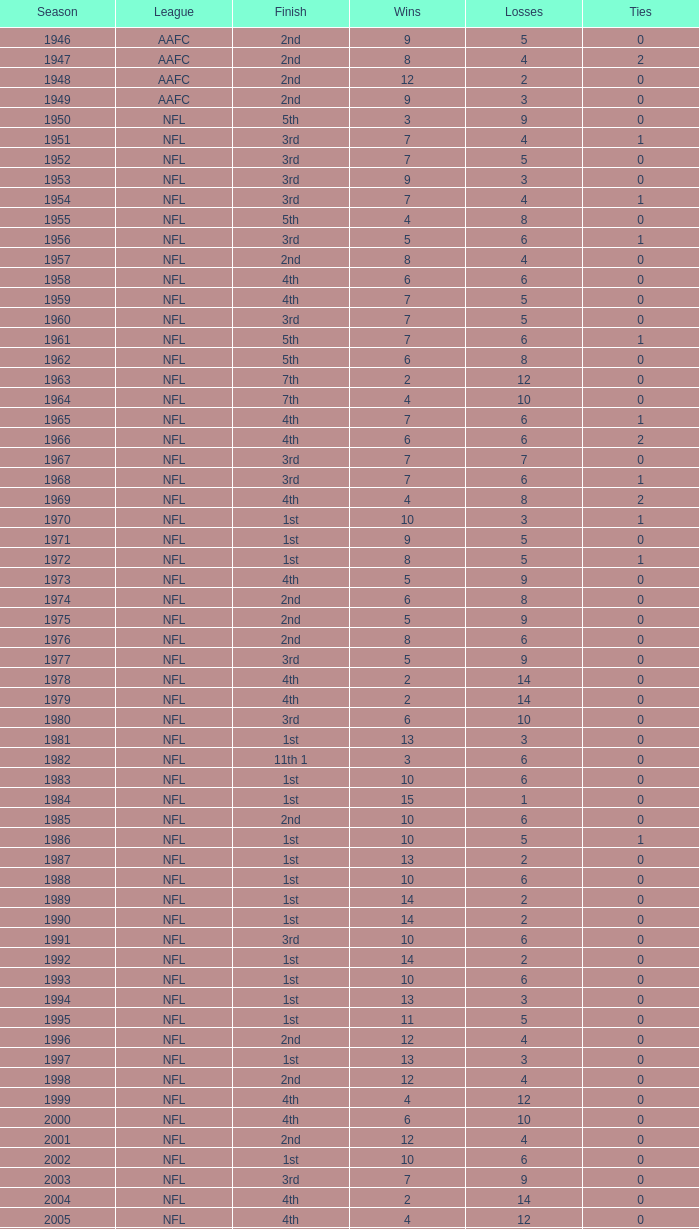Which association experienced a conclusion of 2nd place and 3 defeats? AAFC. I'm looking to parse the entire table for insights. Could you assist me with that? {'header': ['Season', 'League', 'Finish', 'Wins', 'Losses', 'Ties'], 'rows': [['1946', 'AAFC', '2nd', '9', '5', '0'], ['1947', 'AAFC', '2nd', '8', '4', '2'], ['1948', 'AAFC', '2nd', '12', '2', '0'], ['1949', 'AAFC', '2nd', '9', '3', '0'], ['1950', 'NFL', '5th', '3', '9', '0'], ['1951', 'NFL', '3rd', '7', '4', '1'], ['1952', 'NFL', '3rd', '7', '5', '0'], ['1953', 'NFL', '3rd', '9', '3', '0'], ['1954', 'NFL', '3rd', '7', '4', '1'], ['1955', 'NFL', '5th', '4', '8', '0'], ['1956', 'NFL', '3rd', '5', '6', '1'], ['1957', 'NFL', '2nd', '8', '4', '0'], ['1958', 'NFL', '4th', '6', '6', '0'], ['1959', 'NFL', '4th', '7', '5', '0'], ['1960', 'NFL', '3rd', '7', '5', '0'], ['1961', 'NFL', '5th', '7', '6', '1'], ['1962', 'NFL', '5th', '6', '8', '0'], ['1963', 'NFL', '7th', '2', '12', '0'], ['1964', 'NFL', '7th', '4', '10', '0'], ['1965', 'NFL', '4th', '7', '6', '1'], ['1966', 'NFL', '4th', '6', '6', '2'], ['1967', 'NFL', '3rd', '7', '7', '0'], ['1968', 'NFL', '3rd', '7', '6', '1'], ['1969', 'NFL', '4th', '4', '8', '2'], ['1970', 'NFL', '1st', '10', '3', '1'], ['1971', 'NFL', '1st', '9', '5', '0'], ['1972', 'NFL', '1st', '8', '5', '1'], ['1973', 'NFL', '4th', '5', '9', '0'], ['1974', 'NFL', '2nd', '6', '8', '0'], ['1975', 'NFL', '2nd', '5', '9', '0'], ['1976', 'NFL', '2nd', '8', '6', '0'], ['1977', 'NFL', '3rd', '5', '9', '0'], ['1978', 'NFL', '4th', '2', '14', '0'], ['1979', 'NFL', '4th', '2', '14', '0'], ['1980', 'NFL', '3rd', '6', '10', '0'], ['1981', 'NFL', '1st', '13', '3', '0'], ['1982', 'NFL', '11th 1', '3', '6', '0'], ['1983', 'NFL', '1st', '10', '6', '0'], ['1984', 'NFL', '1st', '15', '1', '0'], ['1985', 'NFL', '2nd', '10', '6', '0'], ['1986', 'NFL', '1st', '10', '5', '1'], ['1987', 'NFL', '1st', '13', '2', '0'], ['1988', 'NFL', '1st', '10', '6', '0'], ['1989', 'NFL', '1st', '14', '2', '0'], ['1990', 'NFL', '1st', '14', '2', '0'], ['1991', 'NFL', '3rd', '10', '6', '0'], ['1992', 'NFL', '1st', '14', '2', '0'], ['1993', 'NFL', '1st', '10', '6', '0'], ['1994', 'NFL', '1st', '13', '3', '0'], ['1995', 'NFL', '1st', '11', '5', '0'], ['1996', 'NFL', '2nd', '12', '4', '0'], ['1997', 'NFL', '1st', '13', '3', '0'], ['1998', 'NFL', '2nd', '12', '4', '0'], ['1999', 'NFL', '4th', '4', '12', '0'], ['2000', 'NFL', '4th', '6', '10', '0'], ['2001', 'NFL', '2nd', '12', '4', '0'], ['2002', 'NFL', '1st', '10', '6', '0'], ['2003', 'NFL', '3rd', '7', '9', '0'], ['2004', 'NFL', '4th', '2', '14', '0'], ['2005', 'NFL', '4th', '4', '12', '0'], ['2006', 'NFL', '3rd', '7', '9', '0'], ['2007', 'NFL', '3rd', '5', '11', '0'], ['2008', 'NFL', '2nd', '7', '9', '0'], ['2009', 'NFL', '2nd', '8', '8', '0'], ['2010', 'NFL', '3rd', '6', '10', '0'], ['2011', 'NFL', '1st', '13', '3', '0'], ['2012', 'NFL', '1st', '11', '4', '1'], ['2013', 'NFL', '2nd', '6', '2', '0']]} 